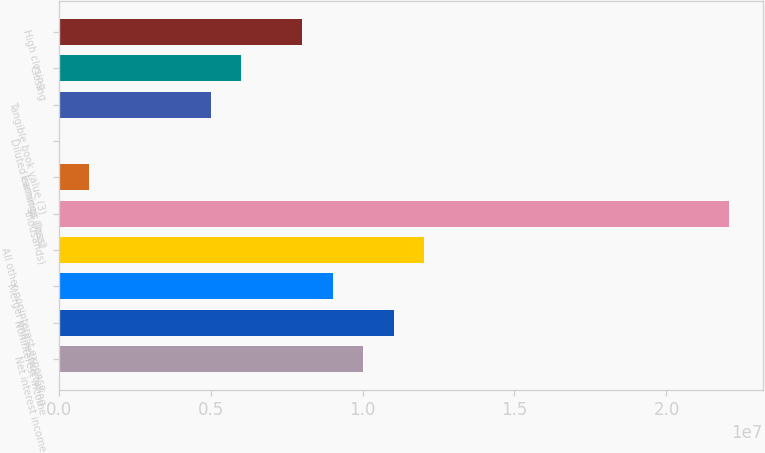<chart> <loc_0><loc_0><loc_500><loc_500><bar_chart><fcel>Net interest income<fcel>Noninterest income<fcel>Merger and restructuring<fcel>All other noninterest expense<fcel>thousands)<fcel>Earnings (loss)<fcel>Diluted earnings (loss)<fcel>Tangible book value (3)<fcel>Closing<fcel>High closing<nl><fcel>1.00298e+07<fcel>1.10328e+07<fcel>9.0268e+06<fcel>1.20357e+07<fcel>2.20655e+07<fcel>1.00298e+06<fcel>0.27<fcel>5.01489e+06<fcel>6.01787e+06<fcel>8.02382e+06<nl></chart> 